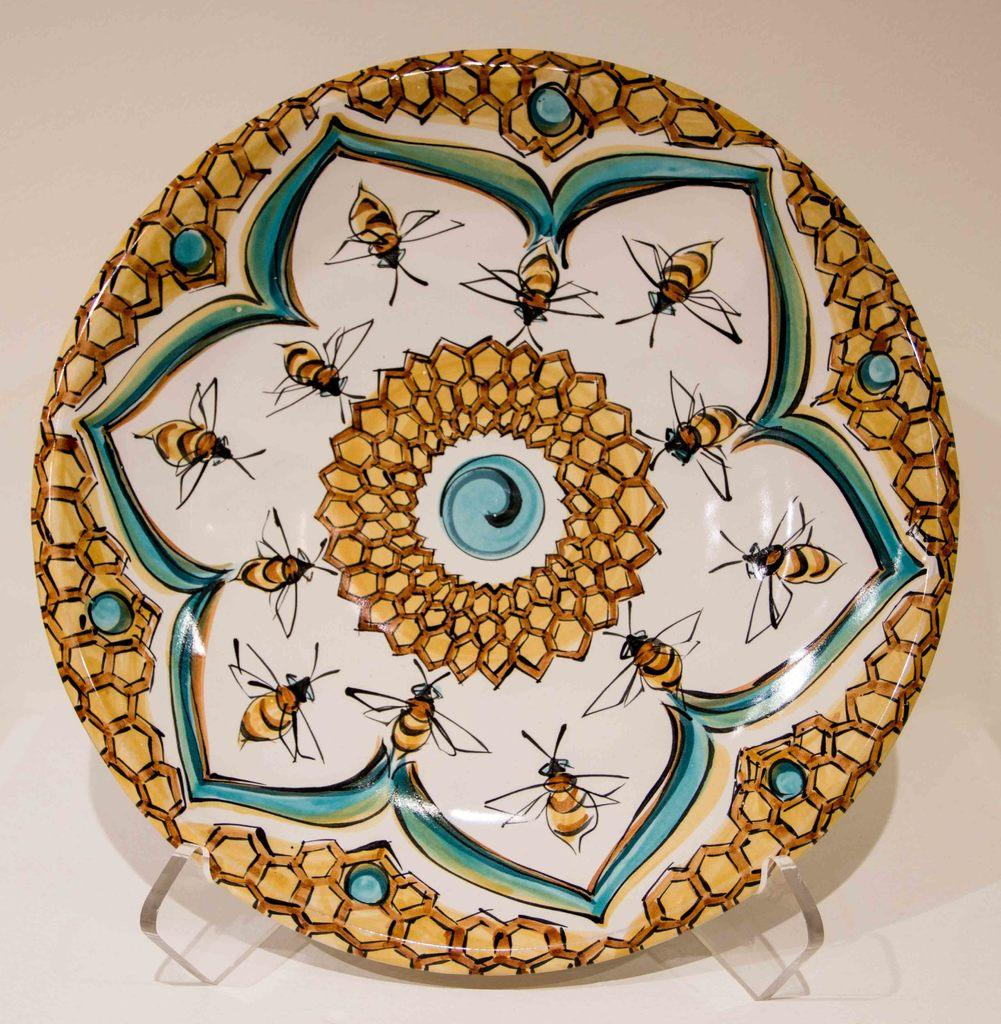What is the main subject of the image? There is a designed object in the image. What type of authority is depicted in the image? There is no authority depicted in the image; it only features a designed object. Is there any writing visible on the designed object in the image? The provided facts do not mention any writing on the designed object, so it cannot be determined from the image. 